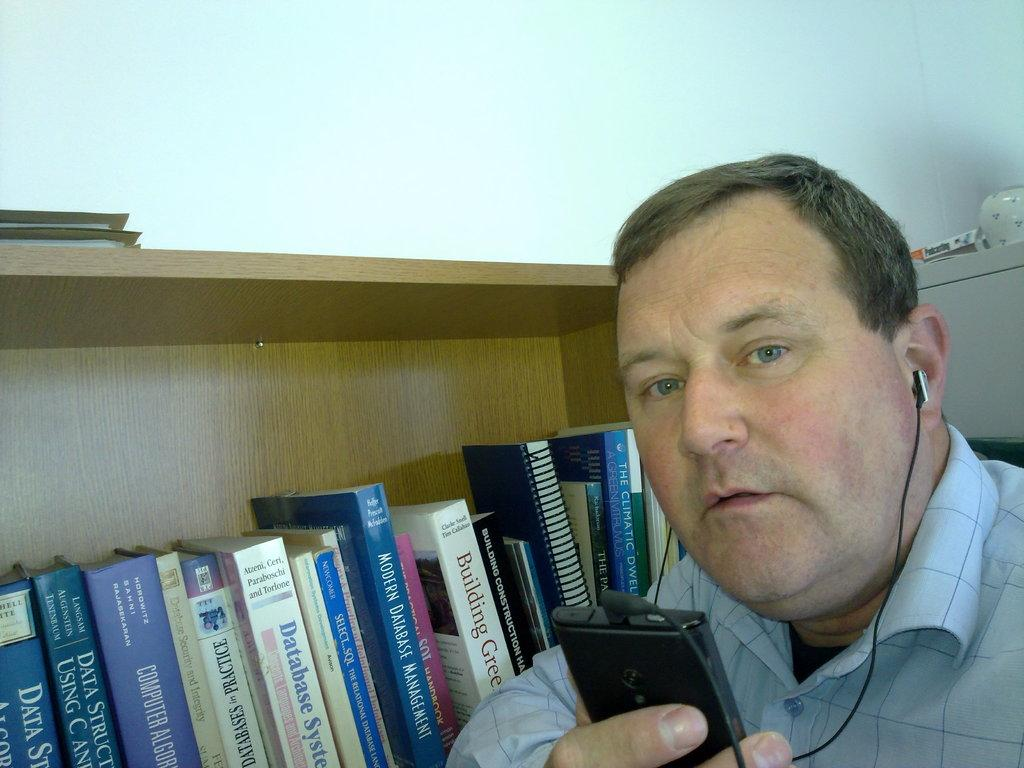Provide a one-sentence caption for the provided image. Modern Database Management is written on the spine of this book. 